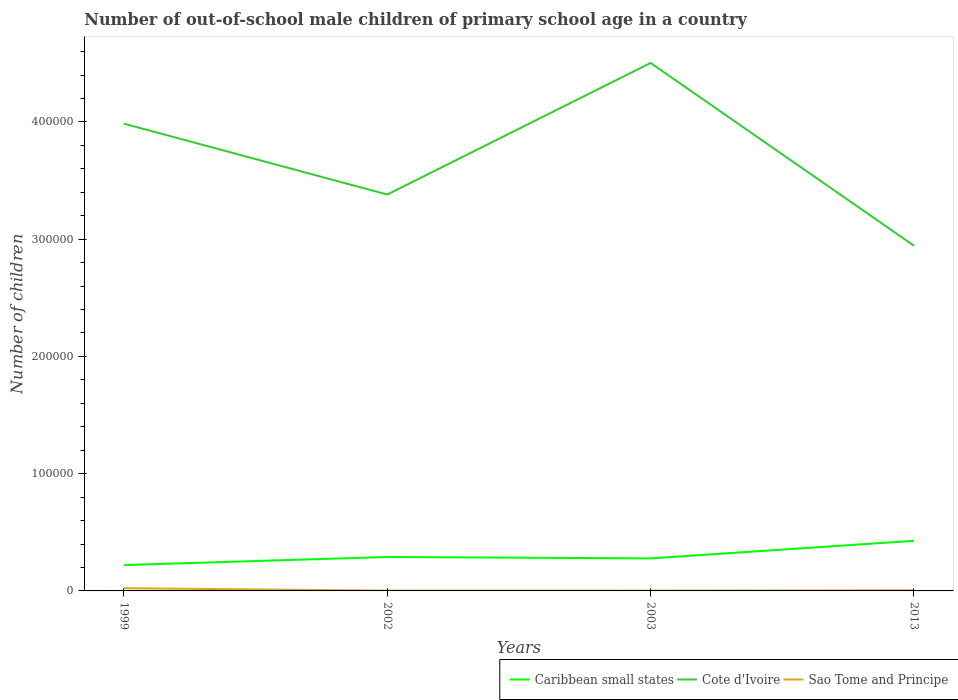Across all years, what is the maximum number of out-of-school male children in Cote d'Ivoire?
Make the answer very short. 2.94e+05. In which year was the number of out-of-school male children in Sao Tome and Principe maximum?
Ensure brevity in your answer.  2003. What is the total number of out-of-school male children in Cote d'Ivoire in the graph?
Provide a succinct answer. -1.12e+05. What is the difference between the highest and the second highest number of out-of-school male children in Cote d'Ivoire?
Provide a short and direct response. 1.56e+05. How many lines are there?
Provide a short and direct response. 3. How many years are there in the graph?
Your answer should be very brief. 4. Are the values on the major ticks of Y-axis written in scientific E-notation?
Provide a short and direct response. No. How are the legend labels stacked?
Ensure brevity in your answer.  Horizontal. What is the title of the graph?
Your response must be concise. Number of out-of-school male children of primary school age in a country. Does "Sao Tome and Principe" appear as one of the legend labels in the graph?
Provide a succinct answer. Yes. What is the label or title of the Y-axis?
Make the answer very short. Number of children. What is the Number of children of Caribbean small states in 1999?
Offer a very short reply. 2.20e+04. What is the Number of children in Cote d'Ivoire in 1999?
Your answer should be compact. 3.99e+05. What is the Number of children of Sao Tome and Principe in 1999?
Your response must be concise. 2290. What is the Number of children of Caribbean small states in 2002?
Your answer should be very brief. 2.89e+04. What is the Number of children of Cote d'Ivoire in 2002?
Make the answer very short. 3.38e+05. What is the Number of children of Sao Tome and Principe in 2002?
Provide a short and direct response. 274. What is the Number of children in Caribbean small states in 2003?
Your answer should be very brief. 2.77e+04. What is the Number of children of Cote d'Ivoire in 2003?
Ensure brevity in your answer.  4.50e+05. What is the Number of children in Sao Tome and Principe in 2003?
Make the answer very short. 248. What is the Number of children in Caribbean small states in 2013?
Give a very brief answer. 4.27e+04. What is the Number of children of Cote d'Ivoire in 2013?
Provide a short and direct response. 2.94e+05. What is the Number of children in Sao Tome and Principe in 2013?
Provide a succinct answer. 513. Across all years, what is the maximum Number of children of Caribbean small states?
Provide a succinct answer. 4.27e+04. Across all years, what is the maximum Number of children in Cote d'Ivoire?
Ensure brevity in your answer.  4.50e+05. Across all years, what is the maximum Number of children in Sao Tome and Principe?
Provide a succinct answer. 2290. Across all years, what is the minimum Number of children in Caribbean small states?
Provide a succinct answer. 2.20e+04. Across all years, what is the minimum Number of children of Cote d'Ivoire?
Ensure brevity in your answer.  2.94e+05. Across all years, what is the minimum Number of children of Sao Tome and Principe?
Keep it short and to the point. 248. What is the total Number of children of Caribbean small states in the graph?
Your answer should be very brief. 1.21e+05. What is the total Number of children of Cote d'Ivoire in the graph?
Your answer should be very brief. 1.48e+06. What is the total Number of children in Sao Tome and Principe in the graph?
Provide a succinct answer. 3325. What is the difference between the Number of children in Caribbean small states in 1999 and that in 2002?
Keep it short and to the point. -6892. What is the difference between the Number of children in Cote d'Ivoire in 1999 and that in 2002?
Provide a short and direct response. 6.04e+04. What is the difference between the Number of children in Sao Tome and Principe in 1999 and that in 2002?
Keep it short and to the point. 2016. What is the difference between the Number of children of Caribbean small states in 1999 and that in 2003?
Offer a terse response. -5700. What is the difference between the Number of children in Cote d'Ivoire in 1999 and that in 2003?
Provide a short and direct response. -5.18e+04. What is the difference between the Number of children in Sao Tome and Principe in 1999 and that in 2003?
Provide a short and direct response. 2042. What is the difference between the Number of children of Caribbean small states in 1999 and that in 2013?
Ensure brevity in your answer.  -2.07e+04. What is the difference between the Number of children of Cote d'Ivoire in 1999 and that in 2013?
Your answer should be very brief. 1.04e+05. What is the difference between the Number of children in Sao Tome and Principe in 1999 and that in 2013?
Offer a very short reply. 1777. What is the difference between the Number of children in Caribbean small states in 2002 and that in 2003?
Your response must be concise. 1192. What is the difference between the Number of children of Cote d'Ivoire in 2002 and that in 2003?
Give a very brief answer. -1.12e+05. What is the difference between the Number of children of Caribbean small states in 2002 and that in 2013?
Your answer should be very brief. -1.38e+04. What is the difference between the Number of children of Cote d'Ivoire in 2002 and that in 2013?
Ensure brevity in your answer.  4.37e+04. What is the difference between the Number of children in Sao Tome and Principe in 2002 and that in 2013?
Give a very brief answer. -239. What is the difference between the Number of children of Caribbean small states in 2003 and that in 2013?
Keep it short and to the point. -1.50e+04. What is the difference between the Number of children in Cote d'Ivoire in 2003 and that in 2013?
Ensure brevity in your answer.  1.56e+05. What is the difference between the Number of children in Sao Tome and Principe in 2003 and that in 2013?
Make the answer very short. -265. What is the difference between the Number of children of Caribbean small states in 1999 and the Number of children of Cote d'Ivoire in 2002?
Offer a very short reply. -3.16e+05. What is the difference between the Number of children in Caribbean small states in 1999 and the Number of children in Sao Tome and Principe in 2002?
Give a very brief answer. 2.18e+04. What is the difference between the Number of children of Cote d'Ivoire in 1999 and the Number of children of Sao Tome and Principe in 2002?
Your answer should be compact. 3.98e+05. What is the difference between the Number of children of Caribbean small states in 1999 and the Number of children of Cote d'Ivoire in 2003?
Provide a short and direct response. -4.28e+05. What is the difference between the Number of children in Caribbean small states in 1999 and the Number of children in Sao Tome and Principe in 2003?
Ensure brevity in your answer.  2.18e+04. What is the difference between the Number of children in Cote d'Ivoire in 1999 and the Number of children in Sao Tome and Principe in 2003?
Your answer should be very brief. 3.98e+05. What is the difference between the Number of children in Caribbean small states in 1999 and the Number of children in Cote d'Ivoire in 2013?
Offer a very short reply. -2.72e+05. What is the difference between the Number of children of Caribbean small states in 1999 and the Number of children of Sao Tome and Principe in 2013?
Give a very brief answer. 2.15e+04. What is the difference between the Number of children in Cote d'Ivoire in 1999 and the Number of children in Sao Tome and Principe in 2013?
Give a very brief answer. 3.98e+05. What is the difference between the Number of children in Caribbean small states in 2002 and the Number of children in Cote d'Ivoire in 2003?
Your response must be concise. -4.21e+05. What is the difference between the Number of children in Caribbean small states in 2002 and the Number of children in Sao Tome and Principe in 2003?
Provide a short and direct response. 2.87e+04. What is the difference between the Number of children of Cote d'Ivoire in 2002 and the Number of children of Sao Tome and Principe in 2003?
Give a very brief answer. 3.38e+05. What is the difference between the Number of children of Caribbean small states in 2002 and the Number of children of Cote d'Ivoire in 2013?
Keep it short and to the point. -2.65e+05. What is the difference between the Number of children in Caribbean small states in 2002 and the Number of children in Sao Tome and Principe in 2013?
Your response must be concise. 2.84e+04. What is the difference between the Number of children in Cote d'Ivoire in 2002 and the Number of children in Sao Tome and Principe in 2013?
Make the answer very short. 3.38e+05. What is the difference between the Number of children of Caribbean small states in 2003 and the Number of children of Cote d'Ivoire in 2013?
Your response must be concise. -2.67e+05. What is the difference between the Number of children in Caribbean small states in 2003 and the Number of children in Sao Tome and Principe in 2013?
Offer a terse response. 2.72e+04. What is the difference between the Number of children in Cote d'Ivoire in 2003 and the Number of children in Sao Tome and Principe in 2013?
Ensure brevity in your answer.  4.50e+05. What is the average Number of children of Caribbean small states per year?
Your response must be concise. 3.04e+04. What is the average Number of children of Cote d'Ivoire per year?
Offer a very short reply. 3.70e+05. What is the average Number of children of Sao Tome and Principe per year?
Offer a very short reply. 831.25. In the year 1999, what is the difference between the Number of children of Caribbean small states and Number of children of Cote d'Ivoire?
Offer a very short reply. -3.76e+05. In the year 1999, what is the difference between the Number of children of Caribbean small states and Number of children of Sao Tome and Principe?
Your response must be concise. 1.98e+04. In the year 1999, what is the difference between the Number of children of Cote d'Ivoire and Number of children of Sao Tome and Principe?
Provide a succinct answer. 3.96e+05. In the year 2002, what is the difference between the Number of children in Caribbean small states and Number of children in Cote d'Ivoire?
Offer a terse response. -3.09e+05. In the year 2002, what is the difference between the Number of children in Caribbean small states and Number of children in Sao Tome and Principe?
Your answer should be compact. 2.87e+04. In the year 2002, what is the difference between the Number of children in Cote d'Ivoire and Number of children in Sao Tome and Principe?
Keep it short and to the point. 3.38e+05. In the year 2003, what is the difference between the Number of children in Caribbean small states and Number of children in Cote d'Ivoire?
Your answer should be compact. -4.23e+05. In the year 2003, what is the difference between the Number of children in Caribbean small states and Number of children in Sao Tome and Principe?
Make the answer very short. 2.75e+04. In the year 2003, what is the difference between the Number of children of Cote d'Ivoire and Number of children of Sao Tome and Principe?
Make the answer very short. 4.50e+05. In the year 2013, what is the difference between the Number of children in Caribbean small states and Number of children in Cote d'Ivoire?
Offer a very short reply. -2.52e+05. In the year 2013, what is the difference between the Number of children in Caribbean small states and Number of children in Sao Tome and Principe?
Your answer should be compact. 4.22e+04. In the year 2013, what is the difference between the Number of children of Cote d'Ivoire and Number of children of Sao Tome and Principe?
Make the answer very short. 2.94e+05. What is the ratio of the Number of children in Caribbean small states in 1999 to that in 2002?
Make the answer very short. 0.76. What is the ratio of the Number of children of Cote d'Ivoire in 1999 to that in 2002?
Ensure brevity in your answer.  1.18. What is the ratio of the Number of children in Sao Tome and Principe in 1999 to that in 2002?
Provide a short and direct response. 8.36. What is the ratio of the Number of children of Caribbean small states in 1999 to that in 2003?
Your answer should be compact. 0.79. What is the ratio of the Number of children in Cote d'Ivoire in 1999 to that in 2003?
Offer a very short reply. 0.89. What is the ratio of the Number of children of Sao Tome and Principe in 1999 to that in 2003?
Provide a succinct answer. 9.23. What is the ratio of the Number of children of Caribbean small states in 1999 to that in 2013?
Ensure brevity in your answer.  0.52. What is the ratio of the Number of children in Cote d'Ivoire in 1999 to that in 2013?
Ensure brevity in your answer.  1.35. What is the ratio of the Number of children of Sao Tome and Principe in 1999 to that in 2013?
Offer a very short reply. 4.46. What is the ratio of the Number of children of Caribbean small states in 2002 to that in 2003?
Your answer should be compact. 1.04. What is the ratio of the Number of children in Cote d'Ivoire in 2002 to that in 2003?
Keep it short and to the point. 0.75. What is the ratio of the Number of children in Sao Tome and Principe in 2002 to that in 2003?
Provide a short and direct response. 1.1. What is the ratio of the Number of children of Caribbean small states in 2002 to that in 2013?
Your response must be concise. 0.68. What is the ratio of the Number of children in Cote d'Ivoire in 2002 to that in 2013?
Provide a short and direct response. 1.15. What is the ratio of the Number of children in Sao Tome and Principe in 2002 to that in 2013?
Make the answer very short. 0.53. What is the ratio of the Number of children in Caribbean small states in 2003 to that in 2013?
Provide a short and direct response. 0.65. What is the ratio of the Number of children in Cote d'Ivoire in 2003 to that in 2013?
Give a very brief answer. 1.53. What is the ratio of the Number of children in Sao Tome and Principe in 2003 to that in 2013?
Keep it short and to the point. 0.48. What is the difference between the highest and the second highest Number of children in Caribbean small states?
Keep it short and to the point. 1.38e+04. What is the difference between the highest and the second highest Number of children of Cote d'Ivoire?
Ensure brevity in your answer.  5.18e+04. What is the difference between the highest and the second highest Number of children in Sao Tome and Principe?
Your response must be concise. 1777. What is the difference between the highest and the lowest Number of children in Caribbean small states?
Keep it short and to the point. 2.07e+04. What is the difference between the highest and the lowest Number of children of Cote d'Ivoire?
Ensure brevity in your answer.  1.56e+05. What is the difference between the highest and the lowest Number of children of Sao Tome and Principe?
Provide a short and direct response. 2042. 